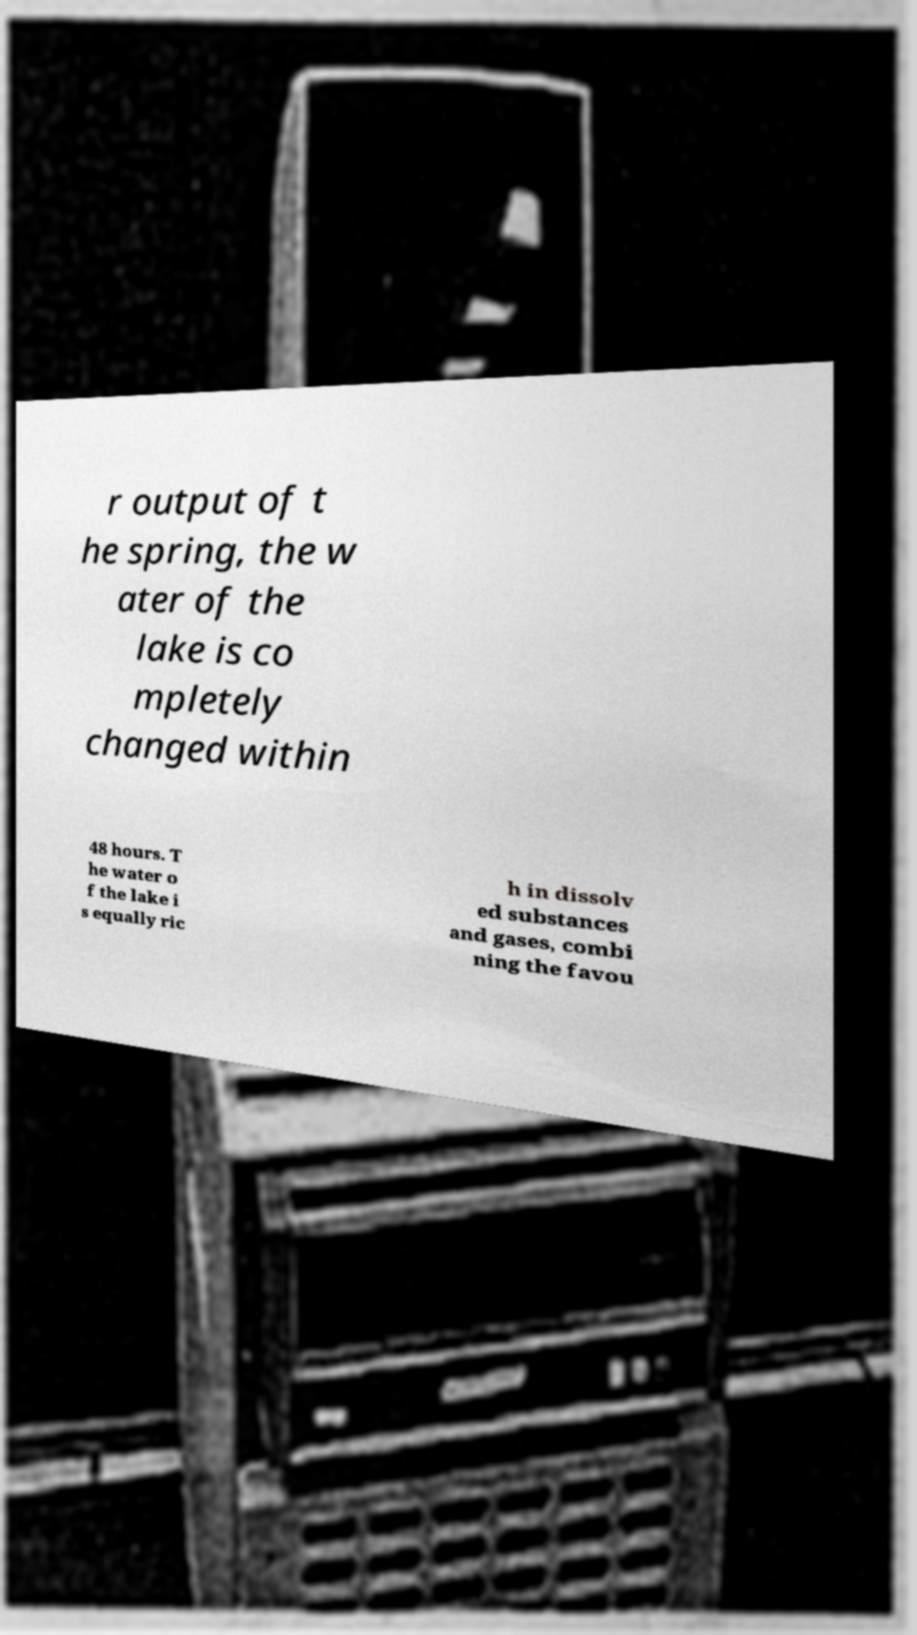For documentation purposes, I need the text within this image transcribed. Could you provide that? r output of t he spring, the w ater of the lake is co mpletely changed within 48 hours. T he water o f the lake i s equally ric h in dissolv ed substances and gases, combi ning the favou 